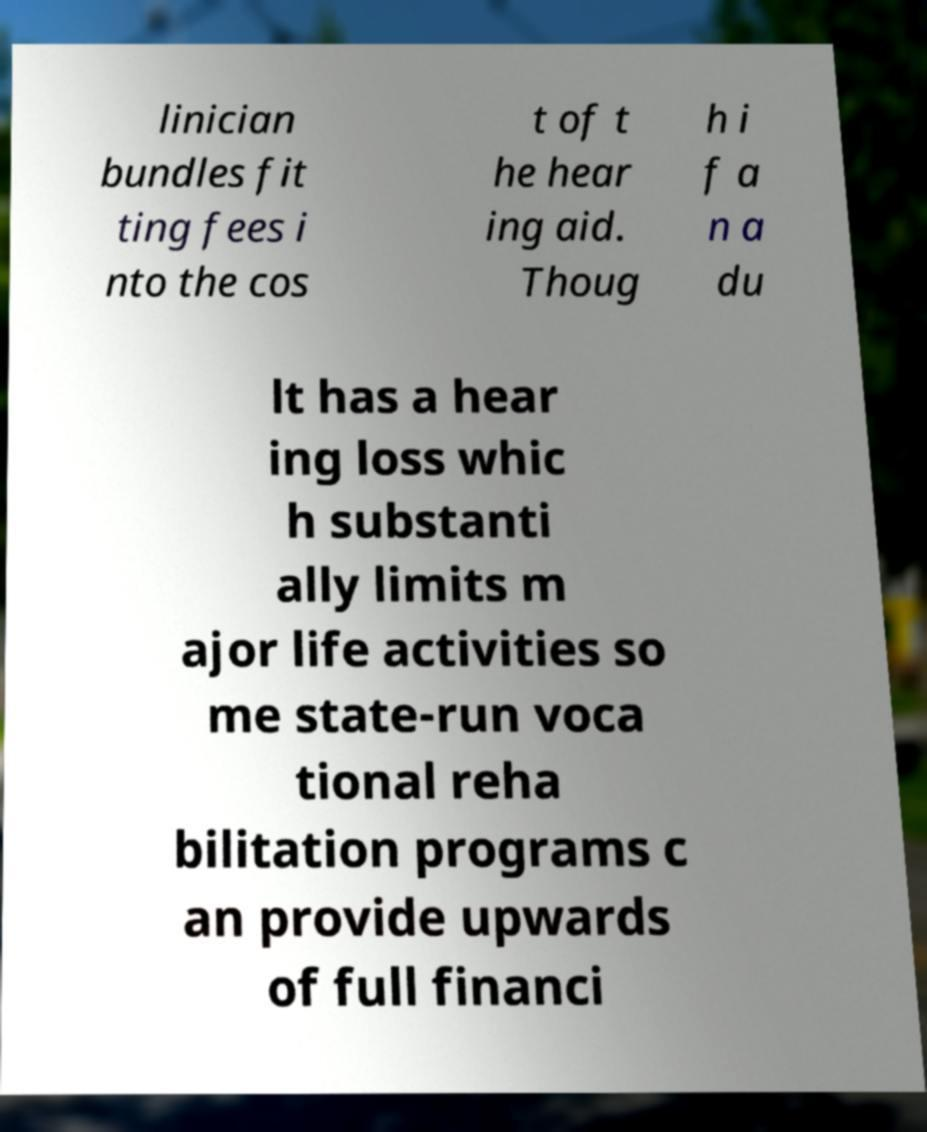Could you assist in decoding the text presented in this image and type it out clearly? linician bundles fit ting fees i nto the cos t of t he hear ing aid. Thoug h i f a n a du lt has a hear ing loss whic h substanti ally limits m ajor life activities so me state-run voca tional reha bilitation programs c an provide upwards of full financi 